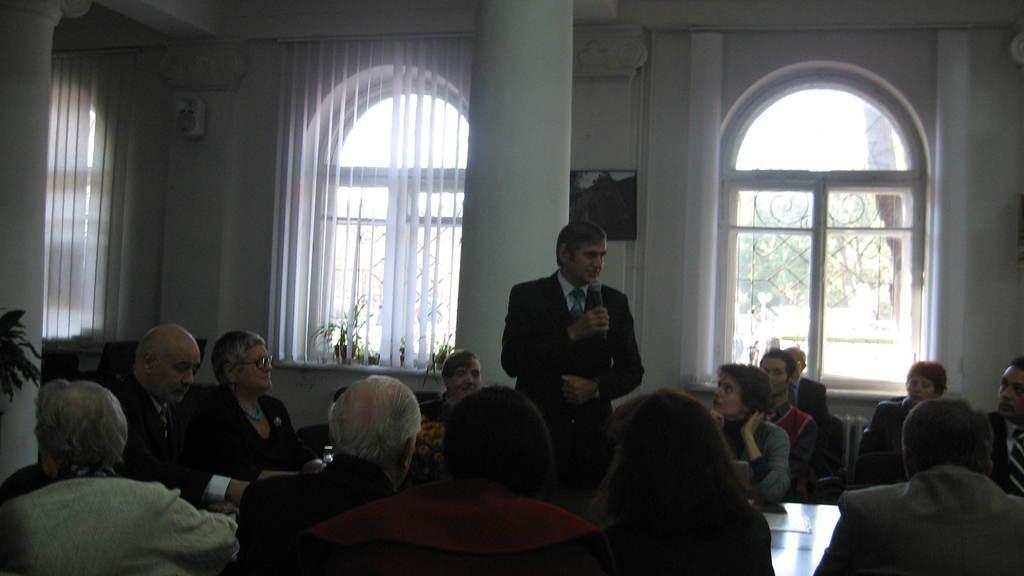Could you give a brief overview of what you see in this image? In this image we can see a man is standing, he is wearing the suit, and holding a microphone in the hands, here are the group of people sitting, here is the window here is the curtain, here is the pillar, here is the wall. 